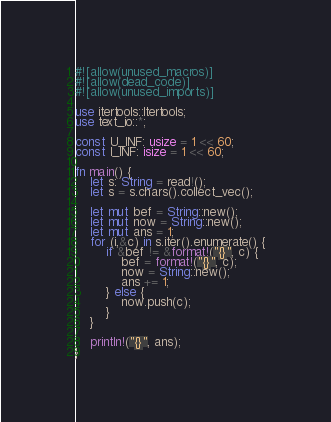Convert code to text. <code><loc_0><loc_0><loc_500><loc_500><_Rust_>#![allow(unused_macros)]
#![allow(dead_code)]
#![allow(unused_imports)]

use itertools::Itertools;
use text_io::*;

const U_INF: usize = 1 << 60;
const I_INF: isize = 1 << 60;

fn main() {
    let s: String = read!();
    let s = s.chars().collect_vec();

    let mut bef = String::new();
    let mut now = String::new();
    let mut ans = 1;
    for (i,&c) in s.iter().enumerate() {
        if &bef != &format!("{}", c) {
            bef = format!("{}", c);
            now = String::new();
            ans += 1;
        } else {
            now.push(c);
        }
    }

    println!("{}", ans);
}
</code> 